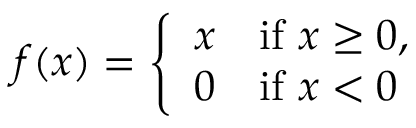<formula> <loc_0><loc_0><loc_500><loc_500>f ( x ) = { \left \{ \begin{array} { l l } { x } & { { i f } x \geq 0 , } \\ { 0 } & { { i f } x < 0 } \end{array} }</formula> 